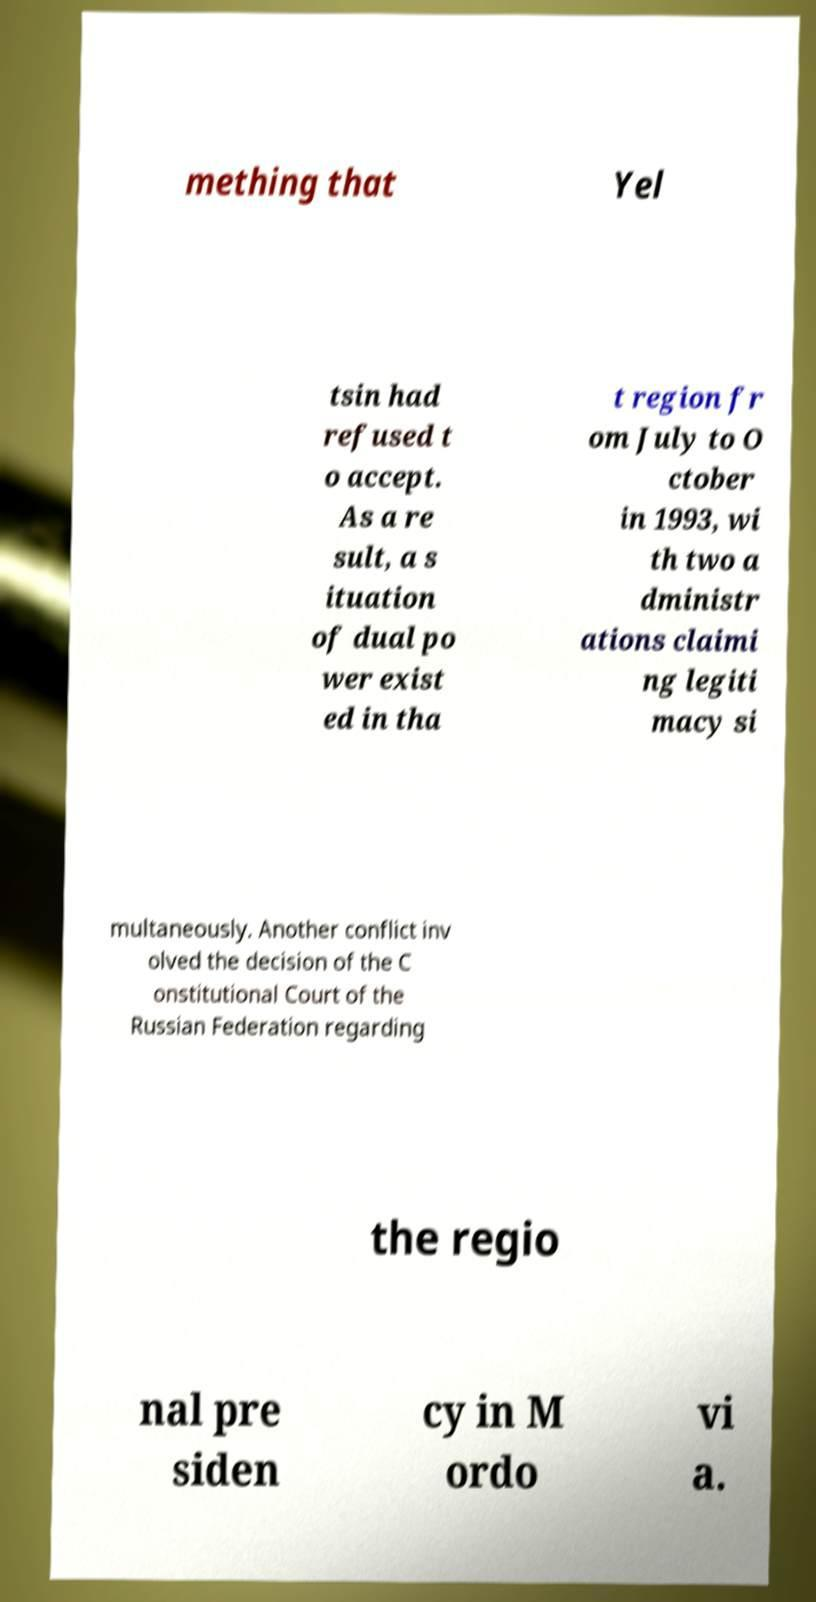Please read and relay the text visible in this image. What does it say? mething that Yel tsin had refused t o accept. As a re sult, a s ituation of dual po wer exist ed in tha t region fr om July to O ctober in 1993, wi th two a dministr ations claimi ng legiti macy si multaneously. Another conflict inv olved the decision of the C onstitutional Court of the Russian Federation regarding the regio nal pre siden cy in M ordo vi a. 